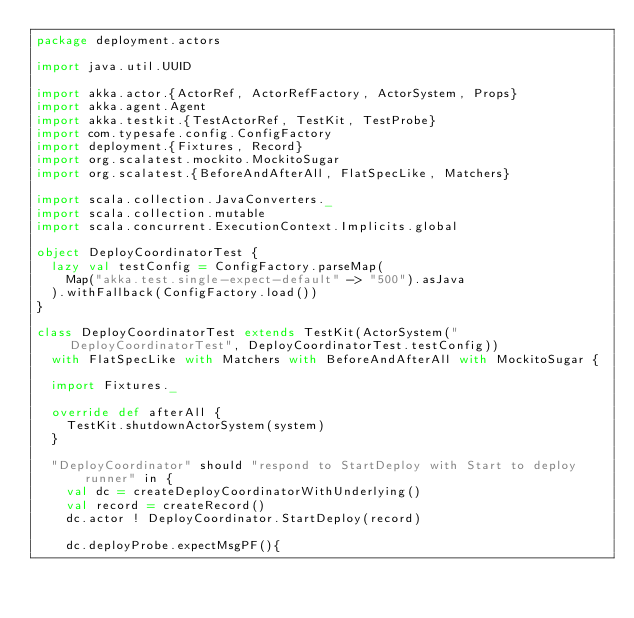Convert code to text. <code><loc_0><loc_0><loc_500><loc_500><_Scala_>package deployment.actors

import java.util.UUID

import akka.actor.{ActorRef, ActorRefFactory, ActorSystem, Props}
import akka.agent.Agent
import akka.testkit.{TestActorRef, TestKit, TestProbe}
import com.typesafe.config.ConfigFactory
import deployment.{Fixtures, Record}
import org.scalatest.mockito.MockitoSugar
import org.scalatest.{BeforeAndAfterAll, FlatSpecLike, Matchers}

import scala.collection.JavaConverters._
import scala.collection.mutable
import scala.concurrent.ExecutionContext.Implicits.global

object DeployCoordinatorTest {
  lazy val testConfig = ConfigFactory.parseMap(
    Map("akka.test.single-expect-default" -> "500").asJava
  ).withFallback(ConfigFactory.load())
}

class DeployCoordinatorTest extends TestKit(ActorSystem("DeployCoordinatorTest", DeployCoordinatorTest.testConfig))
  with FlatSpecLike with Matchers with BeforeAndAfterAll with MockitoSugar {

  import Fixtures._

  override def afterAll {
    TestKit.shutdownActorSystem(system)
  }

  "DeployCoordinator" should "respond to StartDeploy with Start to deploy runner" in {
    val dc = createDeployCoordinatorWithUnderlying()
    val record = createRecord()
    dc.actor ! DeployCoordinator.StartDeploy(record)

    dc.deployProbe.expectMsgPF(){</code> 